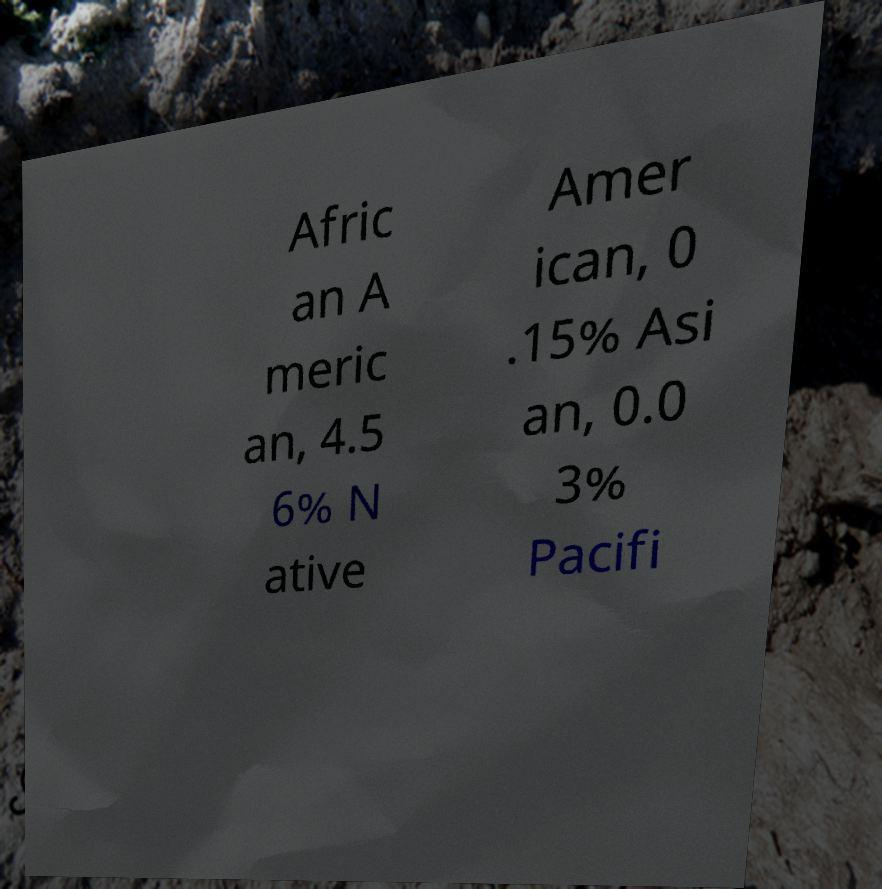For documentation purposes, I need the text within this image transcribed. Could you provide that? Afric an A meric an, 4.5 6% N ative Amer ican, 0 .15% Asi an, 0.0 3% Pacifi 